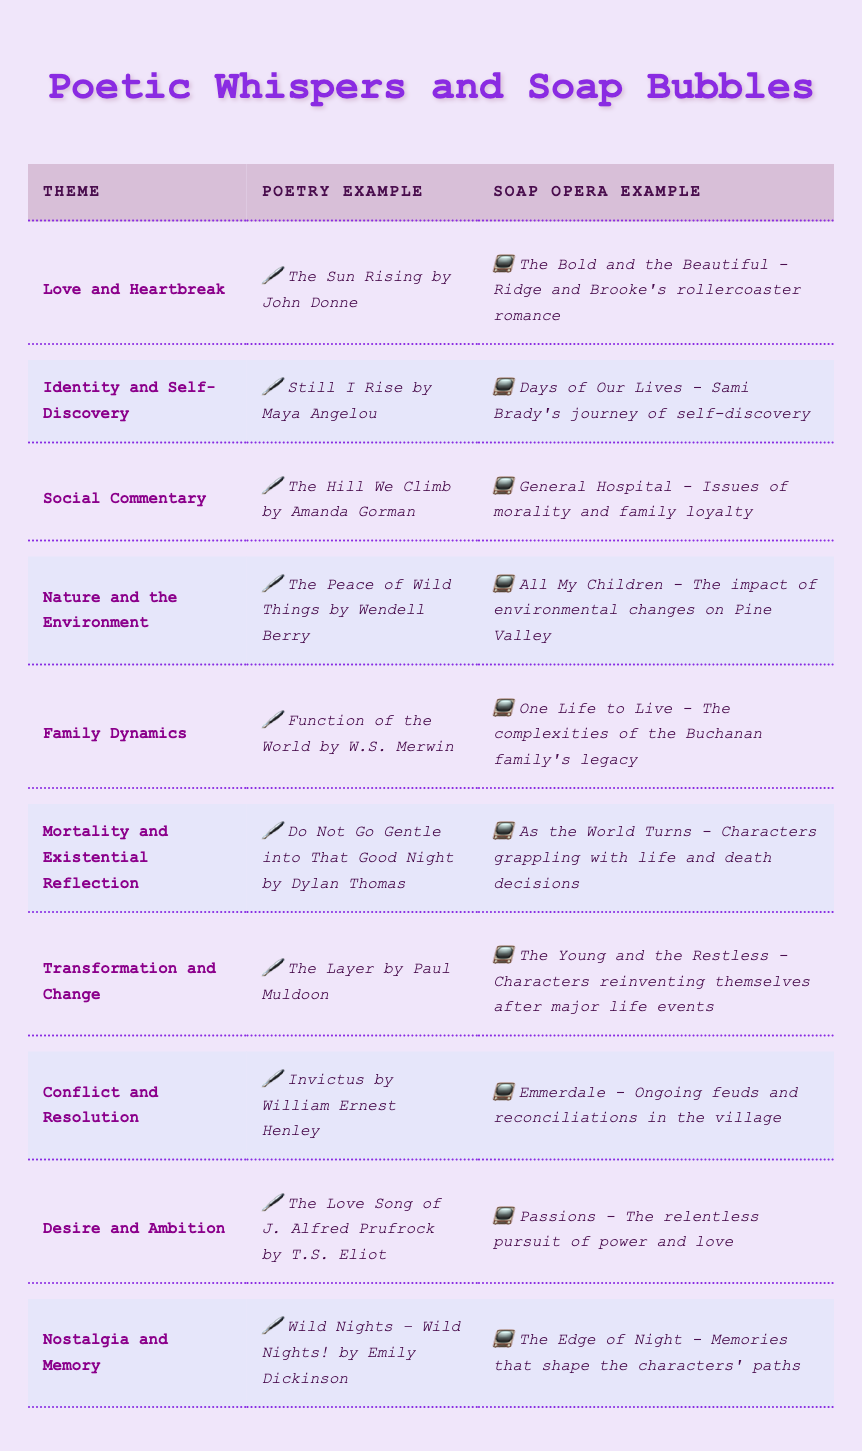What is the example of poetry that corresponds with the theme of "Nature and the Environment"? The theme "Nature and the Environment" is listed in the table, and the poetry example associated with it is "The Peace of Wild Things by Wendell Berry"
Answer: The Peace of Wild Things by Wendell Berry What soap opera example is related to the theme of "Mortality and Existential Reflection"? In the table, the theme "Mortality and Existential Reflection" is matched with the soap opera example "As the World Turns - Characters grappling with life and death decisions"
Answer: As the World Turns - Characters grappling with life and death decisions Is "Desire and Ambition" a theme represented in contemporary poetry? The table includes the theme "Desire and Ambition," which indicates that it is indeed a theme represented in contemporary poetry
Answer: Yes How many themes in the table are associated with a poetry example by Maya Angelou? Scanning the table, I see that the theme "Identity and Self-Discovery" corresponds with Maya Angelou's poem "Still I Rise". Thus, there is only one theme associated with her poetry example
Answer: 1 Which soap opera examples relate to family-related themes? The themes that relate to family dynamics are "Family Dynamics" with the soap opera example "One Life to Live - The complexities of the Buchanan family's legacy" and "Social Commentary" mentioning "General Hospital - Issues of morality and family loyalty". Therefore, there are two themes related to family in the table.
Answer: 2 What is the difference in the number of themes that focus on "Conflict and Resolution" compared to "Transformation and Change"? Both "Conflict and Resolution" and "Transformation and Change" are listed as themes in the table with each having one corresponding poetry example and one soap opera example. Therefore, there is no difference in their counts
Answer: 0 Provide an example of a soap opera plot that matches the theme of "Nostalgia and Memory". According to the table, under the theme "Nostalgia and Memory," the soap opera example given is "The Edge of Night - Memories that shape the characters' paths"
Answer: The Edge of Night - Memories that shape the characters' paths Which poet's work is used to illustrate the theme "Social Commentary"? "The Hill We Climb by Amanda Gorman" is the poetry example listed for the theme "Social Commentary", indicating Amanda Gorman's work is used
Answer: Amanda Gorman Does the theme "Love and Heartbreak" have an associated soap opera example in the table? Yes, the table confirms that the theme "Love and Heartbreak" has the soap opera example "The Bold and the Beautiful - Ridge and Brooke's rollercoaster romance", establishing it as a match
Answer: Yes 